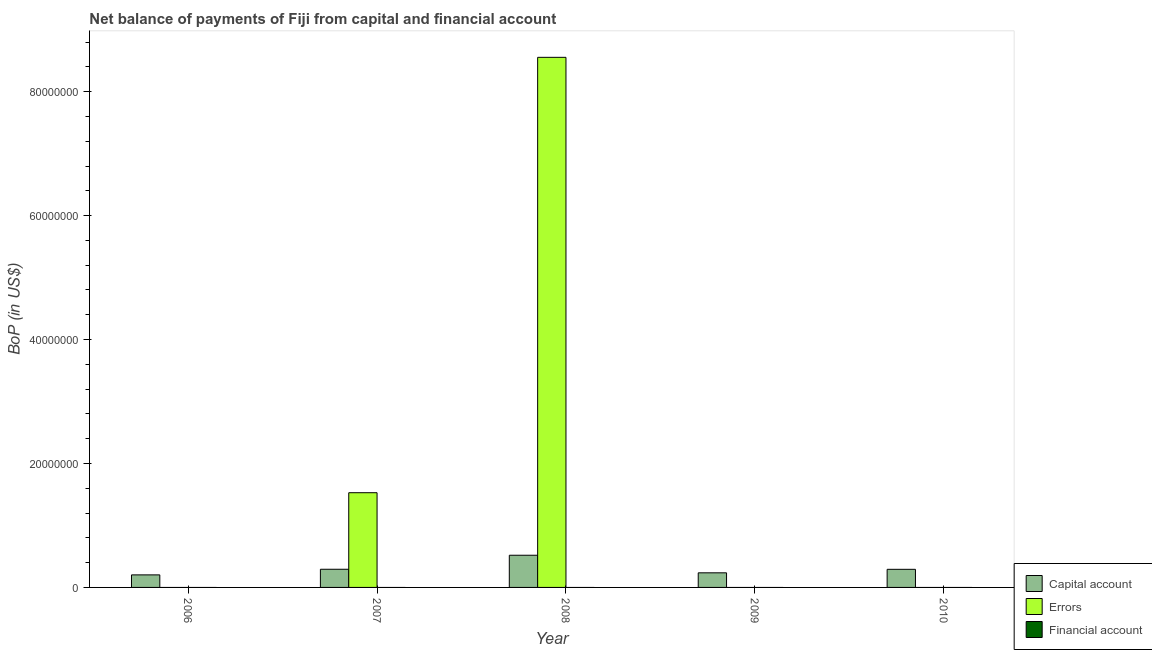Are the number of bars per tick equal to the number of legend labels?
Provide a short and direct response. No. How many bars are there on the 5th tick from the right?
Give a very brief answer. 1. In how many cases, is the number of bars for a given year not equal to the number of legend labels?
Give a very brief answer. 5. What is the amount of errors in 2009?
Your answer should be compact. 0. Across all years, what is the maximum amount of errors?
Your response must be concise. 8.55e+07. Across all years, what is the minimum amount of net capital account?
Your answer should be compact. 2.02e+06. What is the total amount of net capital account in the graph?
Your answer should be compact. 1.54e+07. What is the difference between the amount of net capital account in 2006 and that in 2010?
Give a very brief answer. -8.97e+05. What is the difference between the amount of errors in 2010 and the amount of net capital account in 2008?
Keep it short and to the point. -8.55e+07. What is the average amount of errors per year?
Provide a short and direct response. 2.02e+07. In the year 2009, what is the difference between the amount of net capital account and amount of financial account?
Make the answer very short. 0. What is the ratio of the amount of net capital account in 2007 to that in 2009?
Offer a very short reply. 1.24. Is the difference between the amount of net capital account in 2006 and 2010 greater than the difference between the amount of errors in 2006 and 2010?
Your answer should be compact. No. What is the difference between the highest and the second highest amount of net capital account?
Make the answer very short. 2.26e+06. What is the difference between the highest and the lowest amount of errors?
Make the answer very short. 8.55e+07. How many bars are there?
Provide a short and direct response. 7. Are all the bars in the graph horizontal?
Keep it short and to the point. No. How many years are there in the graph?
Give a very brief answer. 5. Are the values on the major ticks of Y-axis written in scientific E-notation?
Your response must be concise. No. Does the graph contain any zero values?
Provide a short and direct response. Yes. Does the graph contain grids?
Your response must be concise. No. How many legend labels are there?
Your response must be concise. 3. How are the legend labels stacked?
Your response must be concise. Vertical. What is the title of the graph?
Provide a succinct answer. Net balance of payments of Fiji from capital and financial account. What is the label or title of the X-axis?
Make the answer very short. Year. What is the label or title of the Y-axis?
Your response must be concise. BoP (in US$). What is the BoP (in US$) of Capital account in 2006?
Give a very brief answer. 2.02e+06. What is the BoP (in US$) in Financial account in 2006?
Your answer should be very brief. 0. What is the BoP (in US$) in Capital account in 2007?
Offer a very short reply. 2.93e+06. What is the BoP (in US$) of Errors in 2007?
Give a very brief answer. 1.53e+07. What is the BoP (in US$) in Financial account in 2007?
Your response must be concise. 0. What is the BoP (in US$) in Capital account in 2008?
Give a very brief answer. 5.19e+06. What is the BoP (in US$) of Errors in 2008?
Ensure brevity in your answer.  8.55e+07. What is the BoP (in US$) of Financial account in 2008?
Offer a very short reply. 0. What is the BoP (in US$) in Capital account in 2009?
Ensure brevity in your answer.  2.36e+06. What is the BoP (in US$) of Errors in 2009?
Offer a terse response. 0. What is the BoP (in US$) of Capital account in 2010?
Provide a succinct answer. 2.92e+06. Across all years, what is the maximum BoP (in US$) in Capital account?
Provide a succinct answer. 5.19e+06. Across all years, what is the maximum BoP (in US$) in Errors?
Offer a very short reply. 8.55e+07. Across all years, what is the minimum BoP (in US$) of Capital account?
Keep it short and to the point. 2.02e+06. What is the total BoP (in US$) of Capital account in the graph?
Your answer should be very brief. 1.54e+07. What is the total BoP (in US$) in Errors in the graph?
Ensure brevity in your answer.  1.01e+08. What is the total BoP (in US$) in Financial account in the graph?
Your answer should be compact. 0. What is the difference between the BoP (in US$) in Capital account in 2006 and that in 2007?
Your answer should be compact. -9.07e+05. What is the difference between the BoP (in US$) in Capital account in 2006 and that in 2008?
Offer a very short reply. -3.17e+06. What is the difference between the BoP (in US$) of Capital account in 2006 and that in 2009?
Provide a succinct answer. -3.32e+05. What is the difference between the BoP (in US$) of Capital account in 2006 and that in 2010?
Give a very brief answer. -8.97e+05. What is the difference between the BoP (in US$) of Capital account in 2007 and that in 2008?
Keep it short and to the point. -2.26e+06. What is the difference between the BoP (in US$) in Errors in 2007 and that in 2008?
Ensure brevity in your answer.  -7.03e+07. What is the difference between the BoP (in US$) in Capital account in 2007 and that in 2009?
Offer a terse response. 5.76e+05. What is the difference between the BoP (in US$) of Capital account in 2007 and that in 2010?
Give a very brief answer. 1.04e+04. What is the difference between the BoP (in US$) of Capital account in 2008 and that in 2009?
Provide a short and direct response. 2.84e+06. What is the difference between the BoP (in US$) in Capital account in 2008 and that in 2010?
Keep it short and to the point. 2.27e+06. What is the difference between the BoP (in US$) in Capital account in 2009 and that in 2010?
Ensure brevity in your answer.  -5.65e+05. What is the difference between the BoP (in US$) of Capital account in 2006 and the BoP (in US$) of Errors in 2007?
Provide a succinct answer. -1.33e+07. What is the difference between the BoP (in US$) of Capital account in 2006 and the BoP (in US$) of Errors in 2008?
Give a very brief answer. -8.35e+07. What is the difference between the BoP (in US$) in Capital account in 2007 and the BoP (in US$) in Errors in 2008?
Offer a very short reply. -8.26e+07. What is the average BoP (in US$) of Capital account per year?
Provide a succinct answer. 3.09e+06. What is the average BoP (in US$) in Errors per year?
Keep it short and to the point. 2.02e+07. What is the average BoP (in US$) in Financial account per year?
Your answer should be very brief. 0. In the year 2007, what is the difference between the BoP (in US$) in Capital account and BoP (in US$) in Errors?
Offer a terse response. -1.24e+07. In the year 2008, what is the difference between the BoP (in US$) in Capital account and BoP (in US$) in Errors?
Make the answer very short. -8.03e+07. What is the ratio of the BoP (in US$) in Capital account in 2006 to that in 2007?
Give a very brief answer. 0.69. What is the ratio of the BoP (in US$) of Capital account in 2006 to that in 2008?
Provide a succinct answer. 0.39. What is the ratio of the BoP (in US$) in Capital account in 2006 to that in 2009?
Offer a very short reply. 0.86. What is the ratio of the BoP (in US$) in Capital account in 2006 to that in 2010?
Your response must be concise. 0.69. What is the ratio of the BoP (in US$) in Capital account in 2007 to that in 2008?
Provide a short and direct response. 0.56. What is the ratio of the BoP (in US$) in Errors in 2007 to that in 2008?
Keep it short and to the point. 0.18. What is the ratio of the BoP (in US$) in Capital account in 2007 to that in 2009?
Your answer should be very brief. 1.24. What is the ratio of the BoP (in US$) of Capital account in 2007 to that in 2010?
Provide a short and direct response. 1. What is the ratio of the BoP (in US$) of Capital account in 2008 to that in 2009?
Offer a terse response. 2.2. What is the ratio of the BoP (in US$) in Capital account in 2008 to that in 2010?
Give a very brief answer. 1.78. What is the ratio of the BoP (in US$) of Capital account in 2009 to that in 2010?
Provide a succinct answer. 0.81. What is the difference between the highest and the second highest BoP (in US$) in Capital account?
Offer a very short reply. 2.26e+06. What is the difference between the highest and the lowest BoP (in US$) of Capital account?
Make the answer very short. 3.17e+06. What is the difference between the highest and the lowest BoP (in US$) in Errors?
Offer a very short reply. 8.55e+07. 